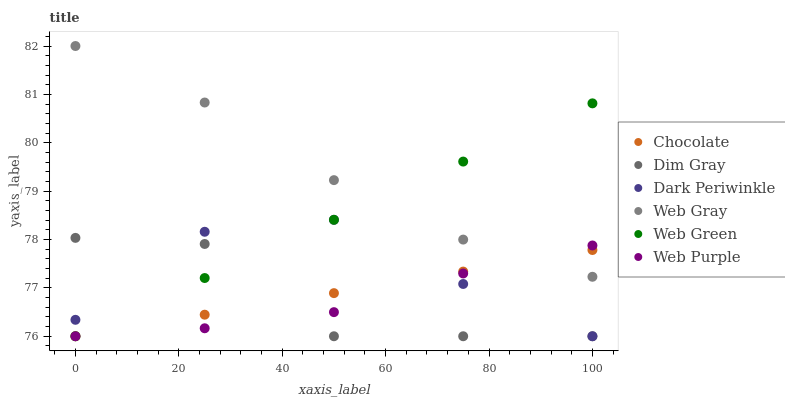Does Web Purple have the minimum area under the curve?
Answer yes or no. Yes. Does Web Gray have the maximum area under the curve?
Answer yes or no. Yes. Does Web Green have the minimum area under the curve?
Answer yes or no. No. Does Web Green have the maximum area under the curve?
Answer yes or no. No. Is Web Green the smoothest?
Answer yes or no. Yes. Is Dim Gray the roughest?
Answer yes or no. Yes. Is Chocolate the smoothest?
Answer yes or no. No. Is Chocolate the roughest?
Answer yes or no. No. Does Dim Gray have the lowest value?
Answer yes or no. Yes. Does Web Gray have the lowest value?
Answer yes or no. No. Does Web Gray have the highest value?
Answer yes or no. Yes. Does Web Green have the highest value?
Answer yes or no. No. Is Dim Gray less than Web Gray?
Answer yes or no. Yes. Is Web Gray greater than Dark Periwinkle?
Answer yes or no. Yes. Does Web Purple intersect Web Green?
Answer yes or no. Yes. Is Web Purple less than Web Green?
Answer yes or no. No. Is Web Purple greater than Web Green?
Answer yes or no. No. Does Dim Gray intersect Web Gray?
Answer yes or no. No. 